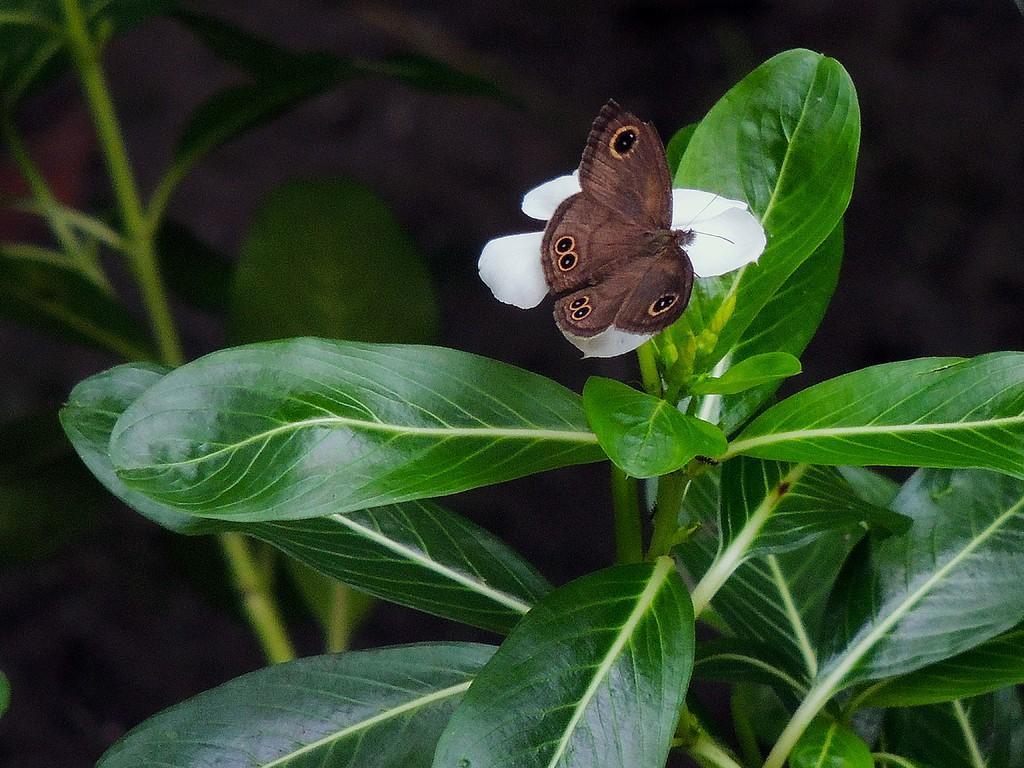Could you give a brief overview of what you see in this image? In this image we can see one butterfly on the white flower, some plants on the ground, one insect looks like an ant on the tree, the background is dark, one plant with one white flower and buds. 